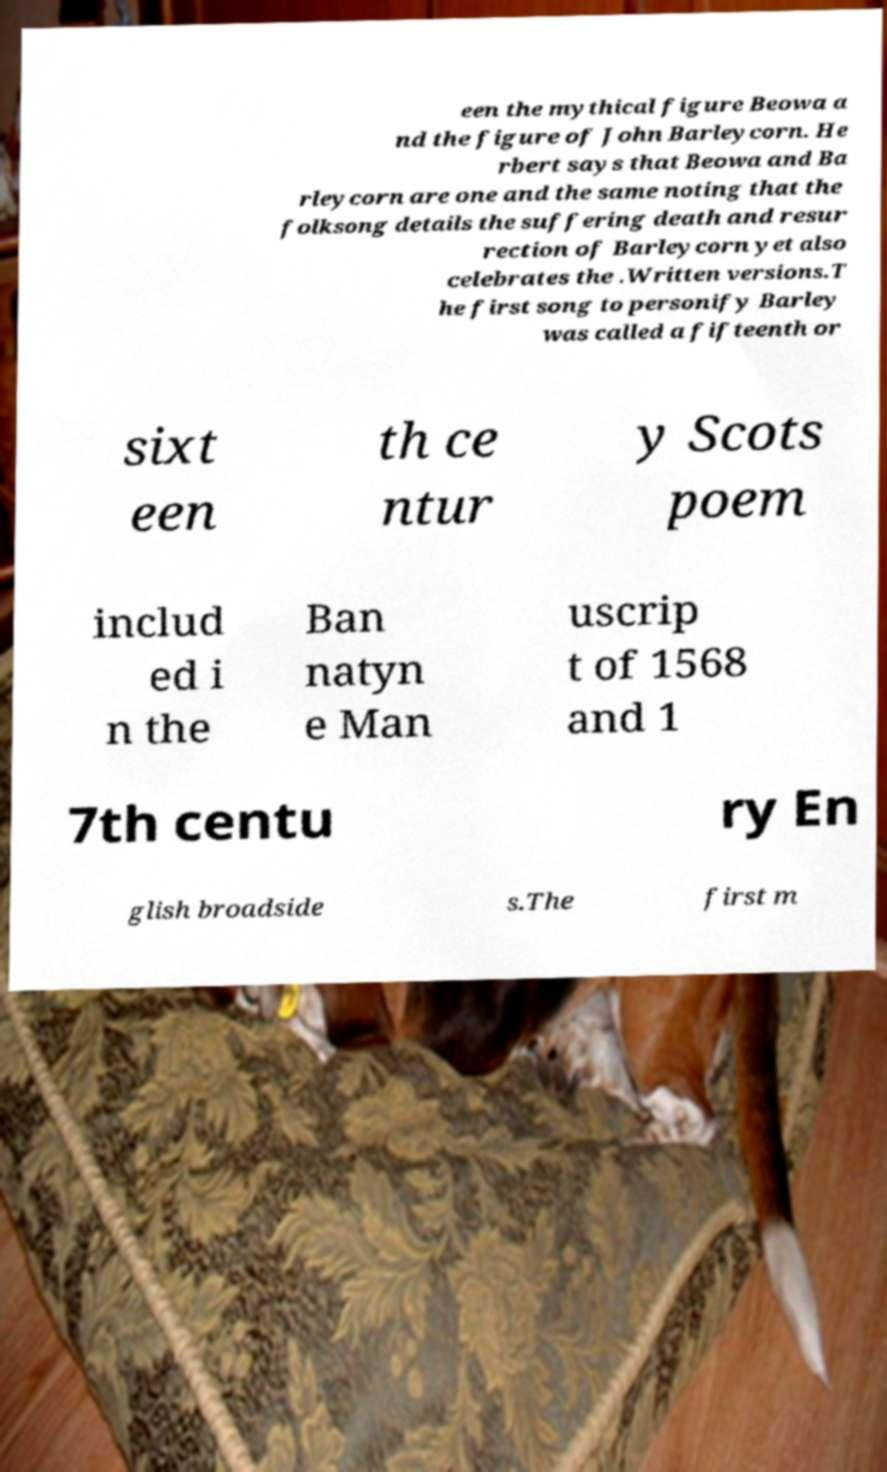Can you read and provide the text displayed in the image?This photo seems to have some interesting text. Can you extract and type it out for me? een the mythical figure Beowa a nd the figure of John Barleycorn. He rbert says that Beowa and Ba rleycorn are one and the same noting that the folksong details the suffering death and resur rection of Barleycorn yet also celebrates the .Written versions.T he first song to personify Barley was called a fifteenth or sixt een th ce ntur y Scots poem includ ed i n the Ban natyn e Man uscrip t of 1568 and 1 7th centu ry En glish broadside s.The first m 